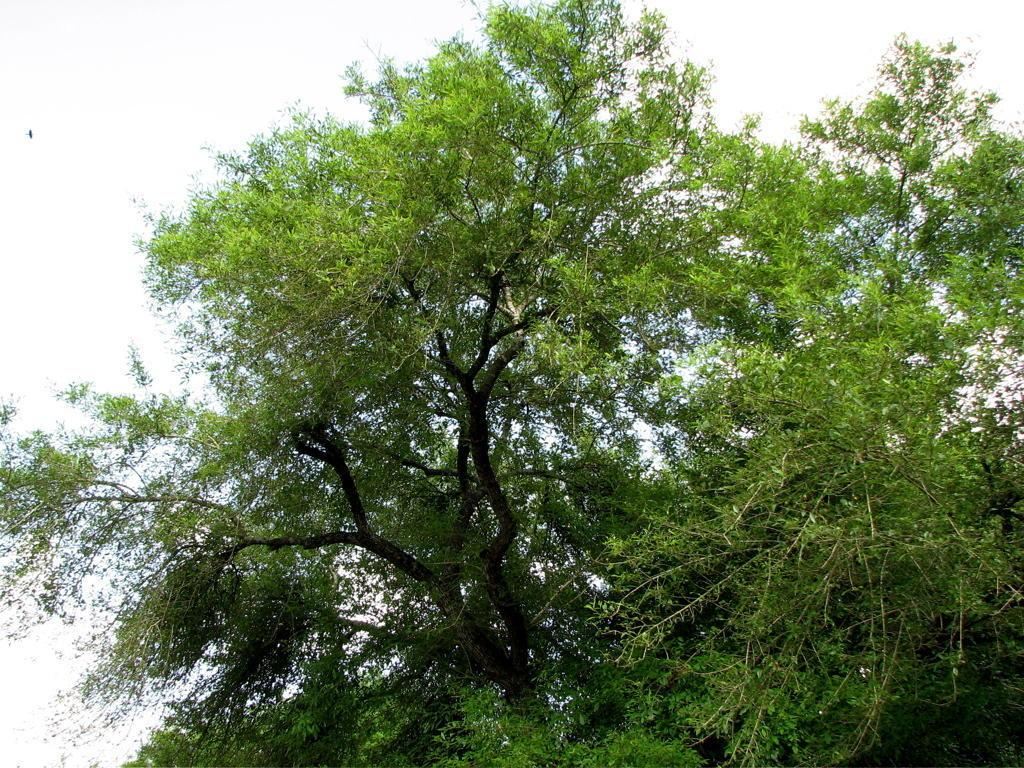What can be seen at the top of the image? The sky is visible in the image. What type of vegetation is present in the image? There is a tree in the image. What type of muscle is visible in the image? There is no muscle visible in the image; it only features a tree and the sky. 